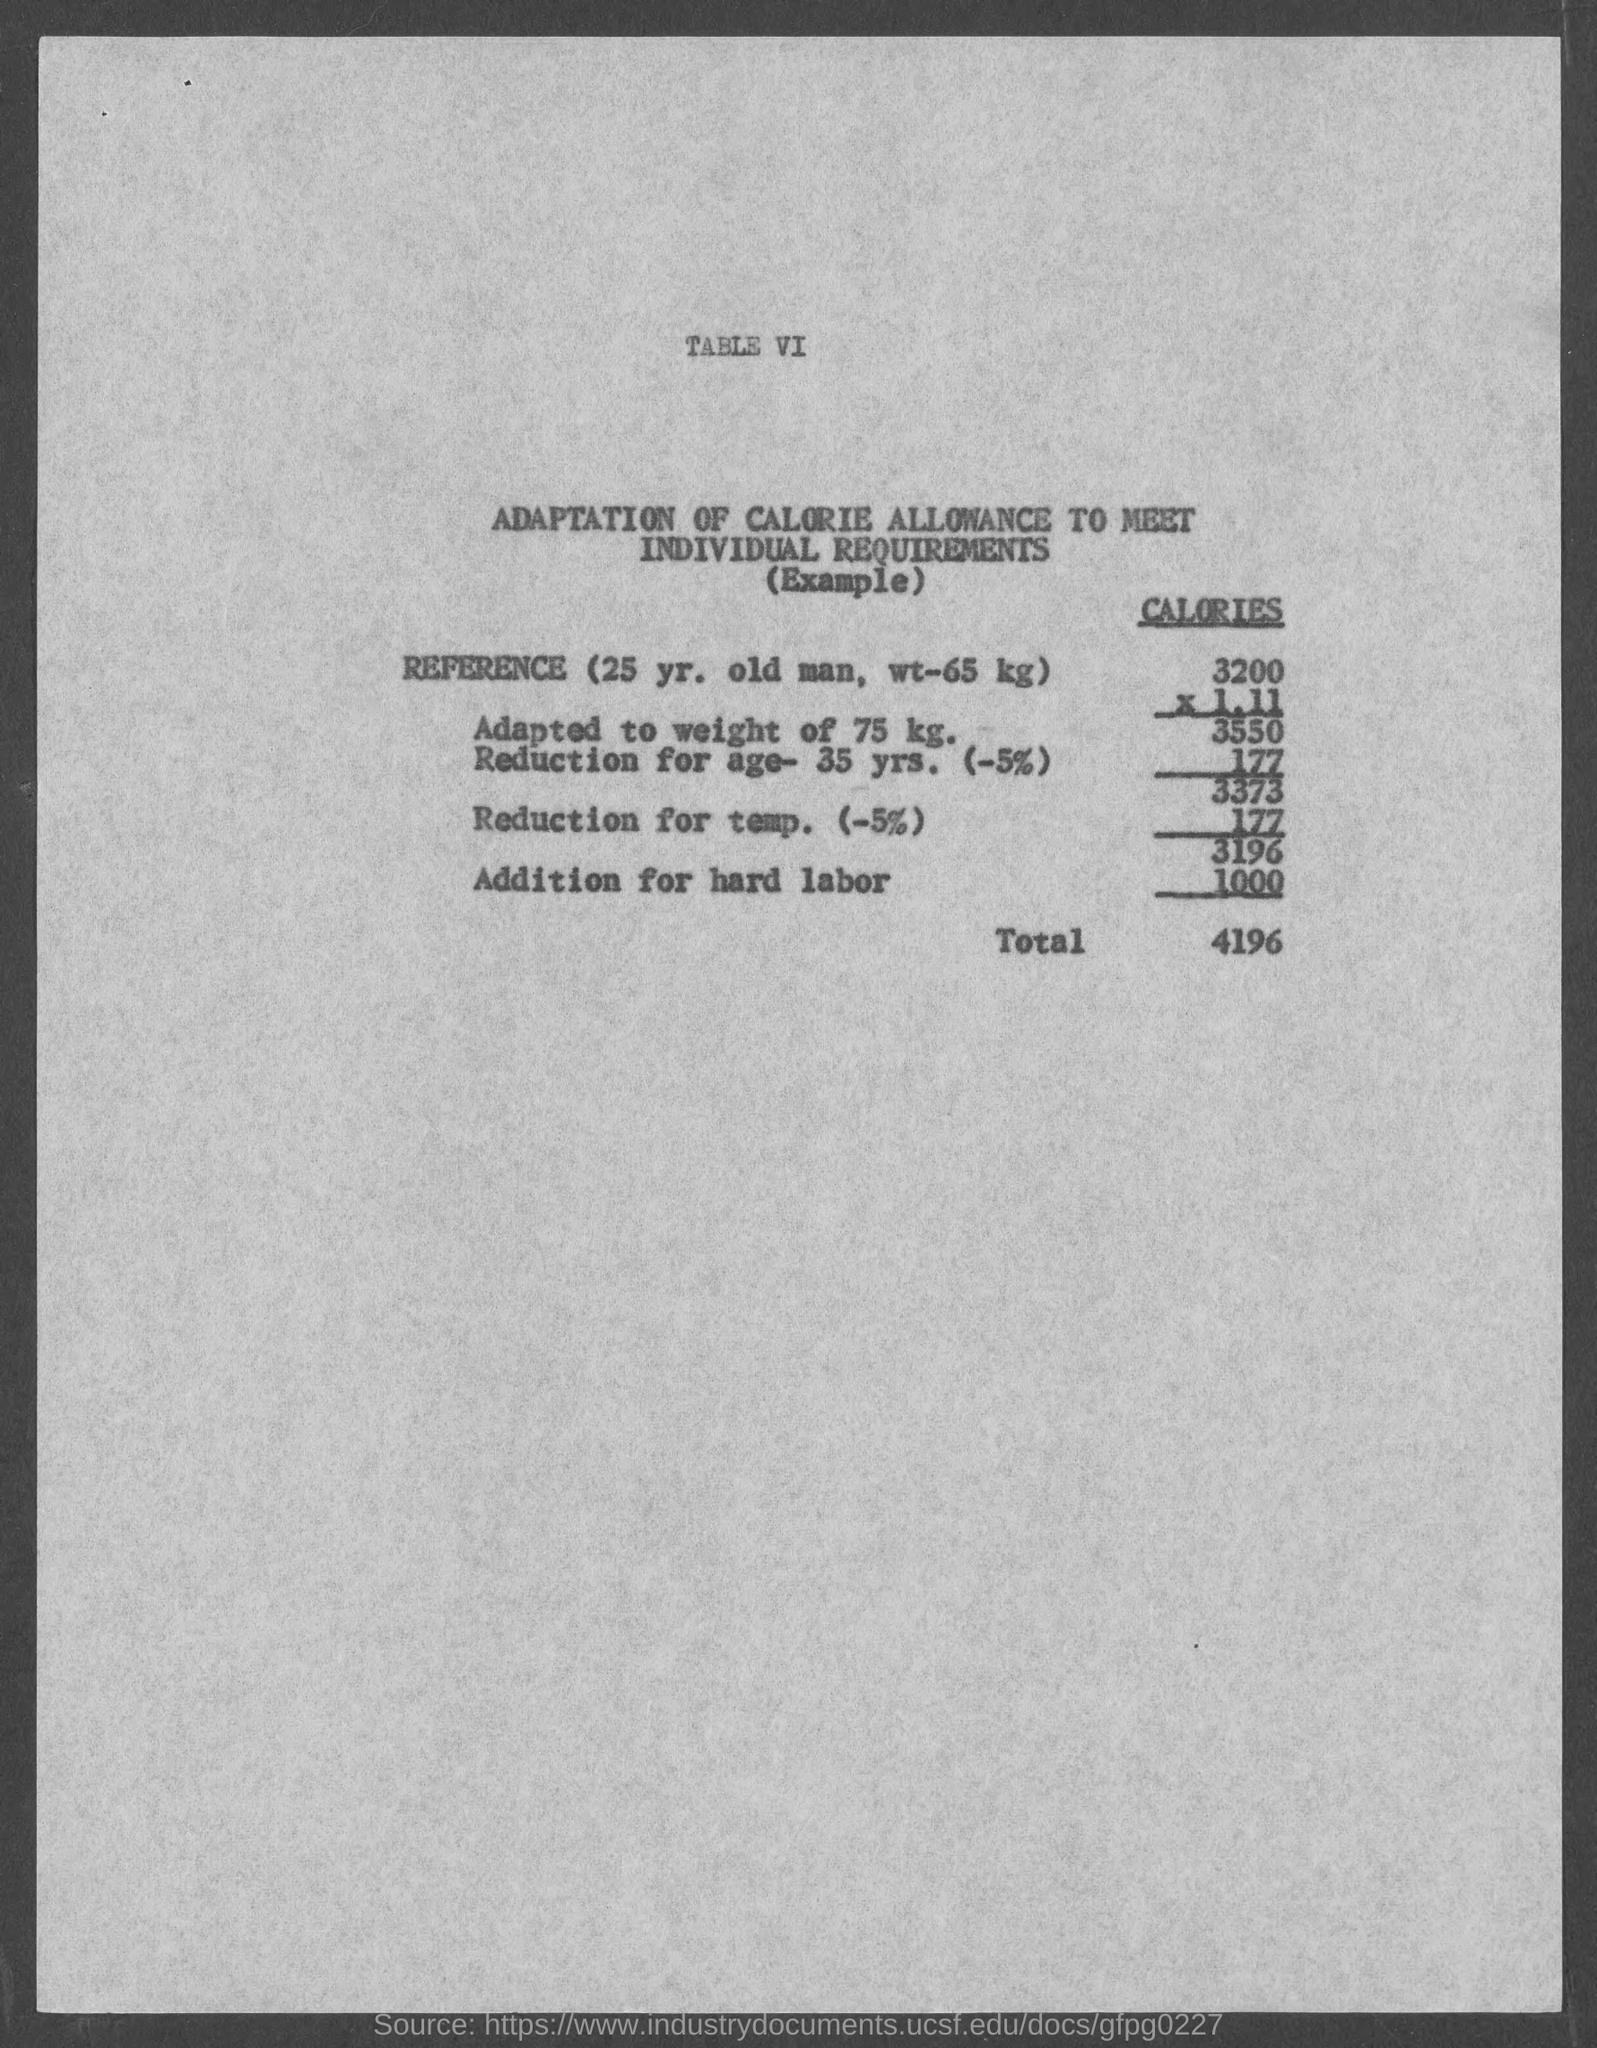Point out several critical features in this image. The reference person is a 25-year-old man. The heading of the table is "Adaptation of Calorie Allowance to Meet Individual Requirements. The total calories are 4196. 